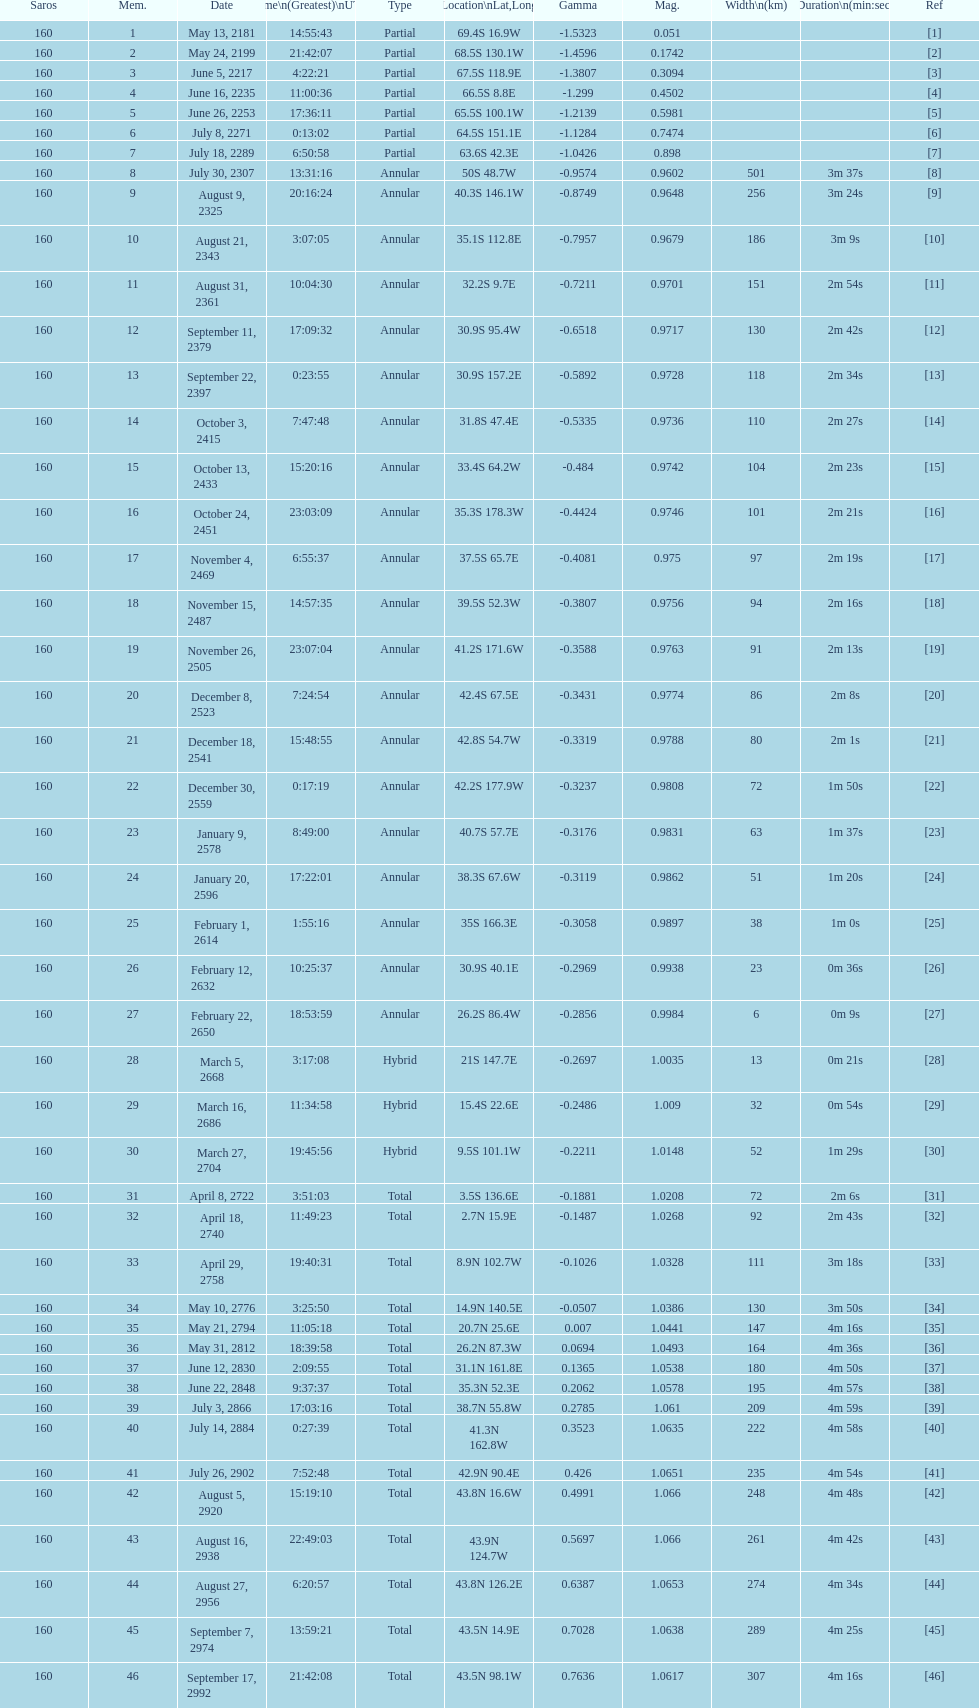Name a member number with a latitude above 60 s. 1. 